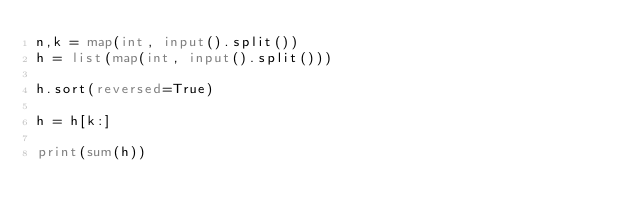<code> <loc_0><loc_0><loc_500><loc_500><_Python_>n,k = map(int, input().split())
h = list(map(int, input().split()))

h.sort(reversed=True)

h = h[k:]

print(sum(h))</code> 